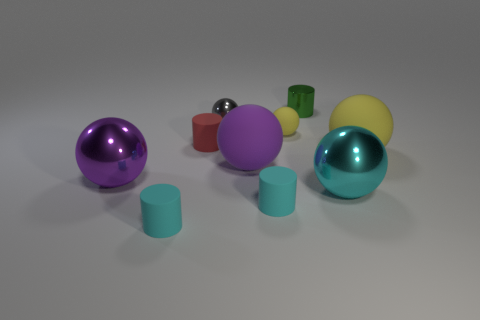How would you describe the arrangement and composition of the objects in this image? The objects are arranged asymmetrically on a flat surface with a neutral background, creating a balanced but dynamic composition. The assortment includes spheres and cylinders in various sizes and colors that create visual interest through their forms and reflective textures. 